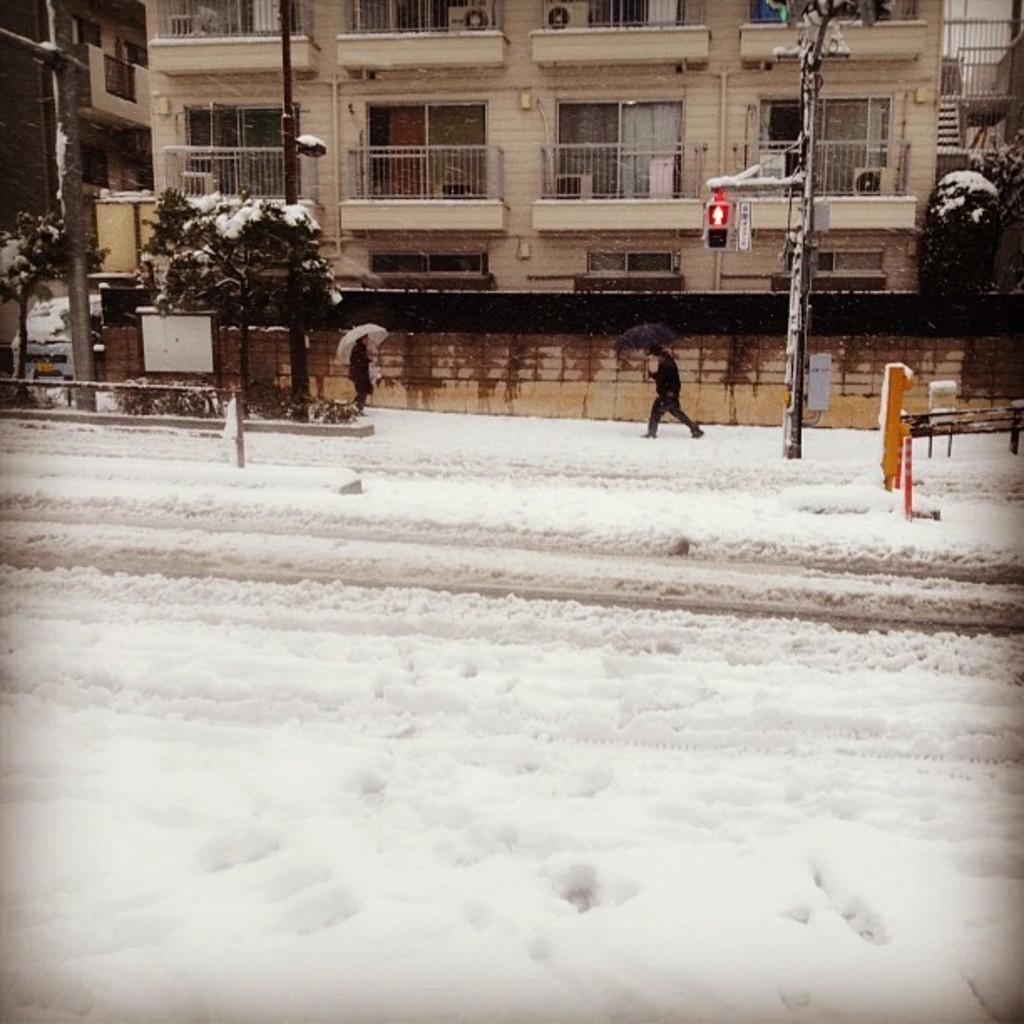Can you describe this image briefly? In this image, we can see buildings, trees, poles and at the bottom, we can see people holding umbrellas and walking on the snow. 